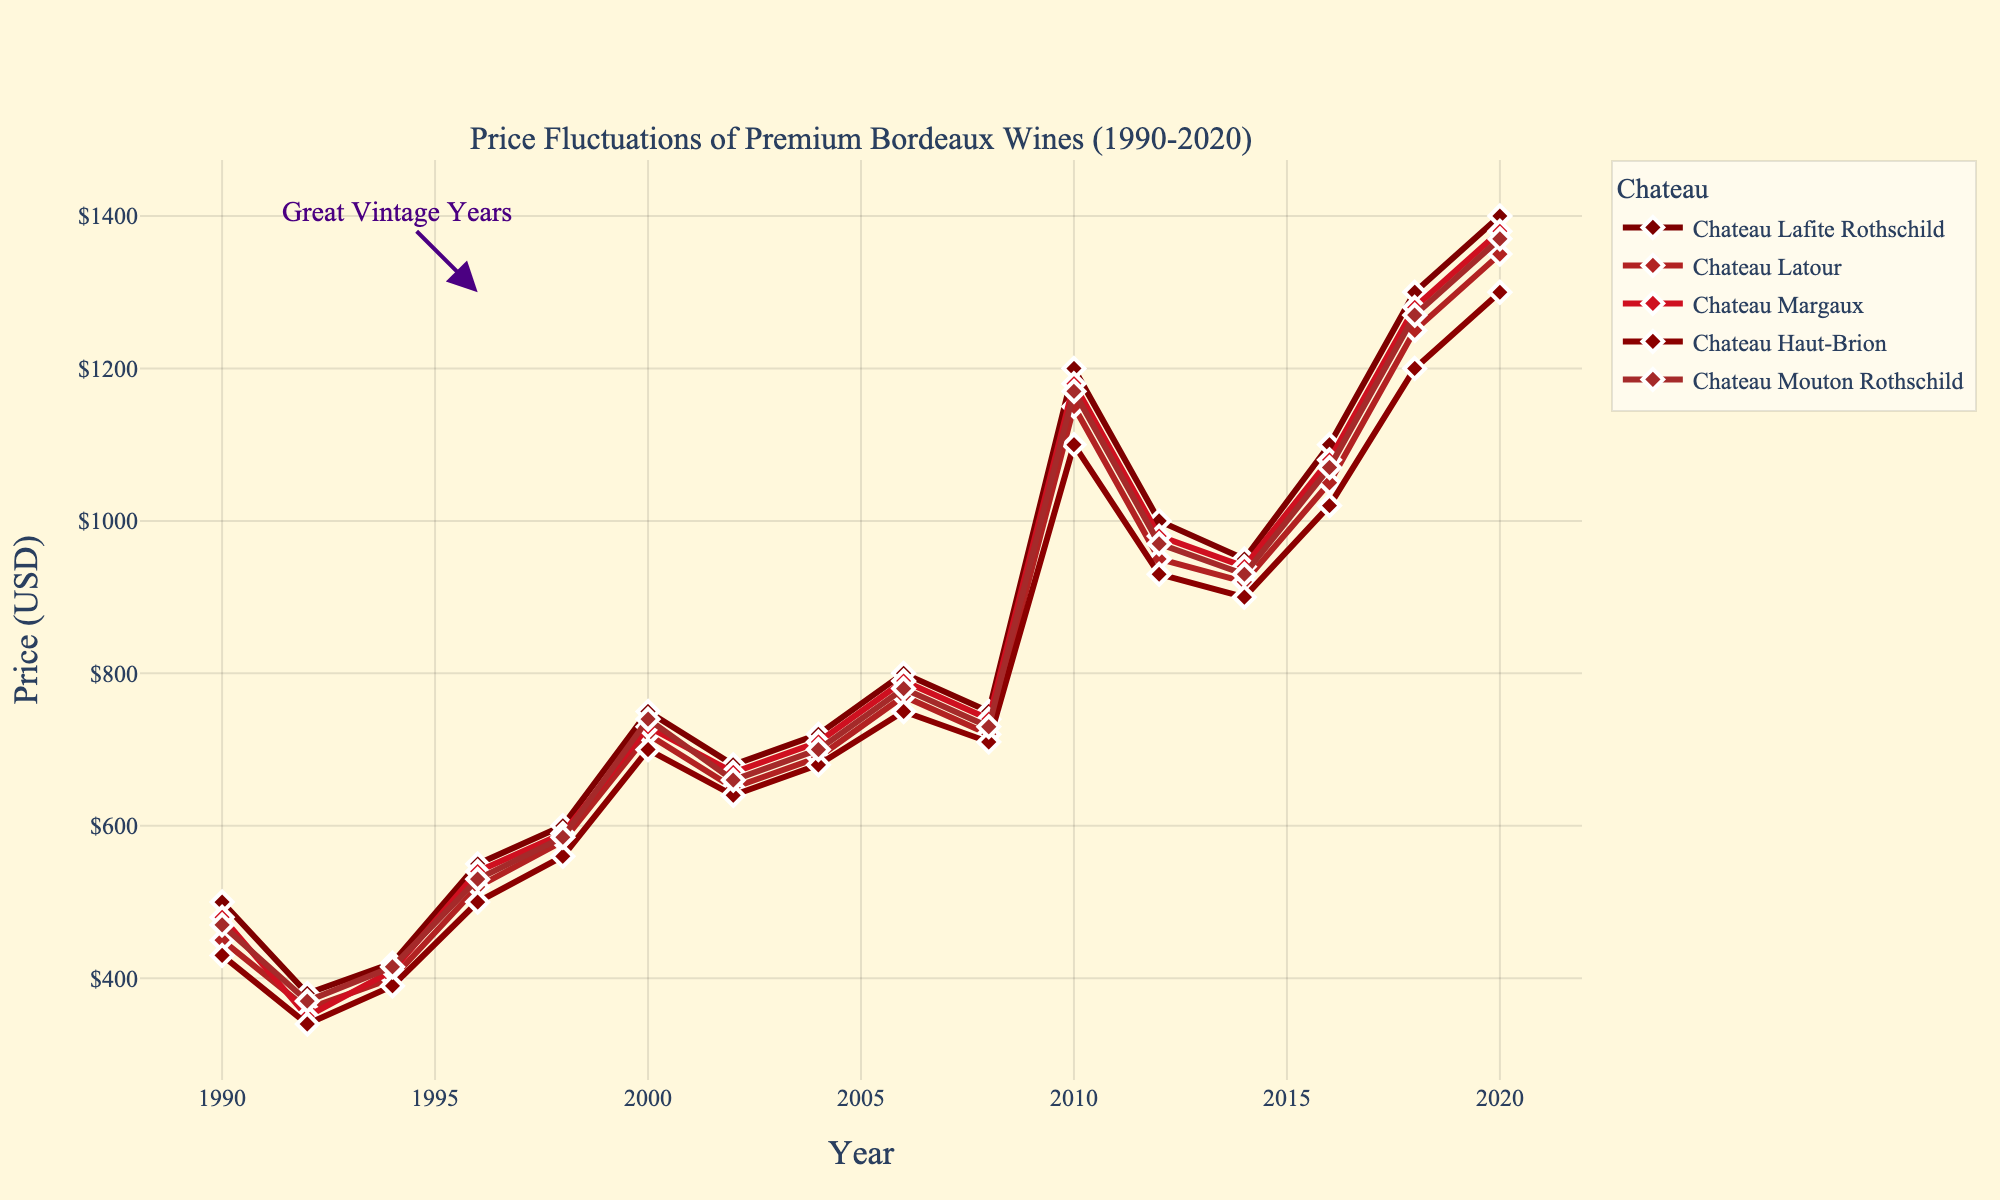Which Chateau had the highest price in 2020? Observe the endpoint of the lines for the year 2020 on the x-axis. Find the line with the highest value on the y-axis at that point.
Answer: Chateau Lafite Rothschild How did the price of Chateau Margaux change from 2008 to 2010? Look at the data points for Chateau Margaux in the years 2008 and 2010 and calculate the difference.
Answer: Increased by $440 Which year showed the most significant increase in the price of Chateau Latour? Compare the price differences year by year for Chateau Latour and find the year with the largest difference.
Answer: 2010 What is the average price of Chateau Haut-Brion from 1990 to 2020? Sum the prices of Chateau Haut-Brion for all listed years and divide by the number of years (15). The sum is $12,860 divided by 15.
Answer: $857.33 Which Chateau had the lowest price in the year 2016? Observe the lines at the year 2016 on the x-axis and identify the line with the lowest value on the y-axis.
Answer: Chateau Haut-Brion Between which consecutive years did Chateau Mouton Rothschild experience the smallest price change? Calculate the price difference between each consecutive year for Chateau Mouton Rothschild and identify the smallest one.
Answer: 2008 to 2010 What was the difference in price between Chateau Lafite Rothschild and Chateau Haut-Brion in the year 2000? Find the price of both chateaux in the year 2000 and subtract the price of Chateau Haut-Brion from Chateau Lafite Rothschild.
Answer: $50 In which year did all Chateaux experience a price peak? Identify the year where all chateau lines reach a peak collectively.
Answer: 2010 By how much did the average price of all five chateaux increase from 1998 to 2000? Calculate the average price for 1998 and 2000, then find the difference. The average price of 1998 is $583, and for 2000 it is $728. The increase is 728 - 583.
Answer: $145 Which Chateau's price remained relatively stable between 2012 and 2016? Compare the price changes for each Chateau between 2012 and 2016, and identify the one with the least significant changes.
Answer: Chateau Haut-Brion 